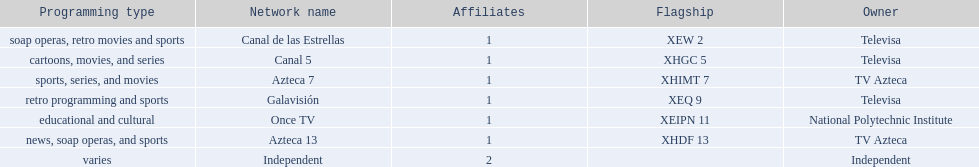How many networks do not air sports? 2. 